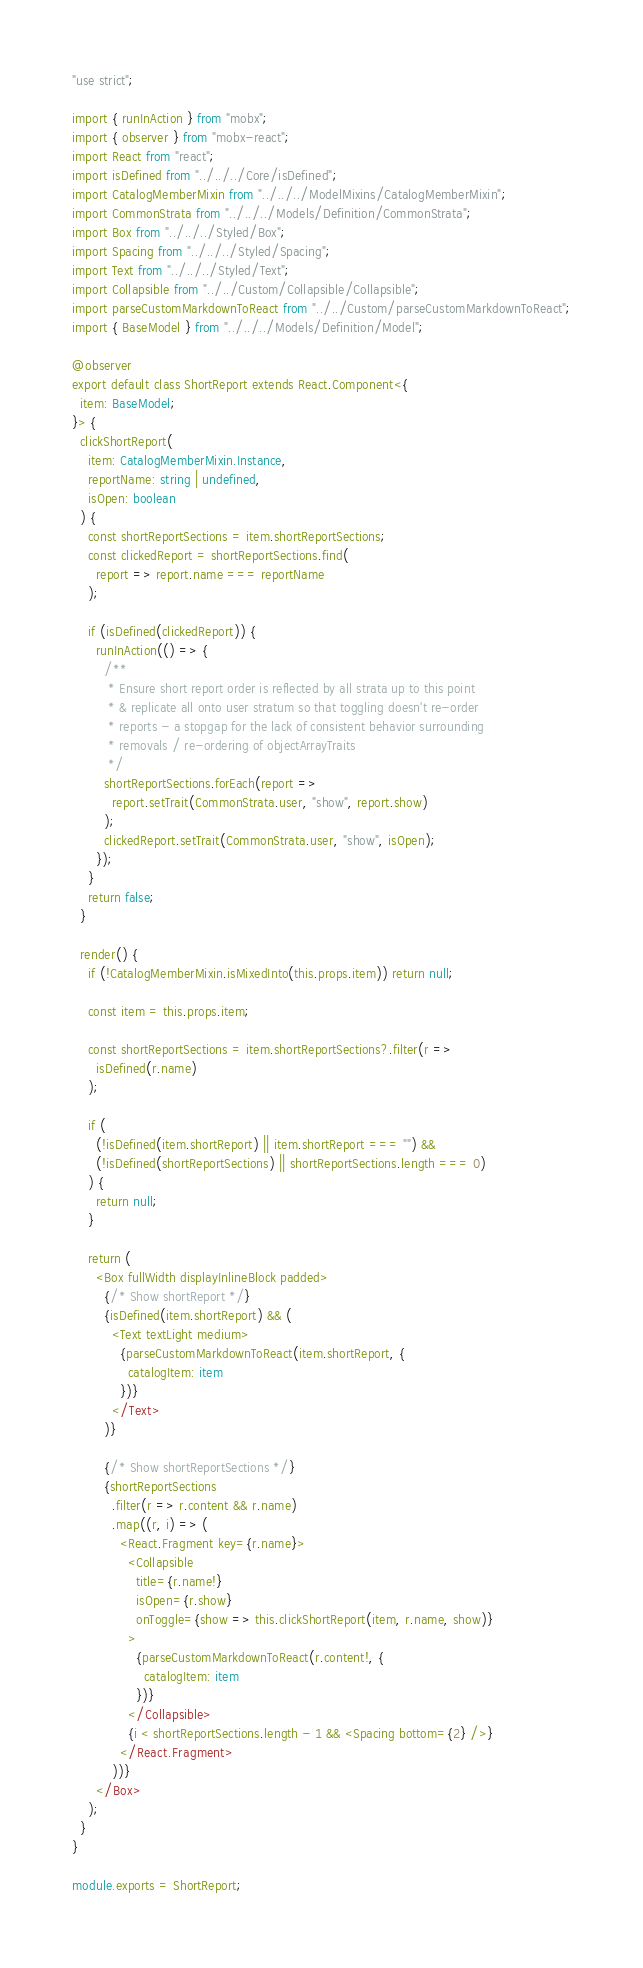Convert code to text. <code><loc_0><loc_0><loc_500><loc_500><_TypeScript_>"use strict";

import { runInAction } from "mobx";
import { observer } from "mobx-react";
import React from "react";
import isDefined from "../../../Core/isDefined";
import CatalogMemberMixin from "../../../ModelMixins/CatalogMemberMixin";
import CommonStrata from "../../../Models/Definition/CommonStrata";
import Box from "../../../Styled/Box";
import Spacing from "../../../Styled/Spacing";
import Text from "../../../Styled/Text";
import Collapsible from "../../Custom/Collapsible/Collapsible";
import parseCustomMarkdownToReact from "../../Custom/parseCustomMarkdownToReact";
import { BaseModel } from "../../../Models/Definition/Model";

@observer
export default class ShortReport extends React.Component<{
  item: BaseModel;
}> {
  clickShortReport(
    item: CatalogMemberMixin.Instance,
    reportName: string | undefined,
    isOpen: boolean
  ) {
    const shortReportSections = item.shortReportSections;
    const clickedReport = shortReportSections.find(
      report => report.name === reportName
    );

    if (isDefined(clickedReport)) {
      runInAction(() => {
        /**
         * Ensure short report order is reflected by all strata up to this point
         * & replicate all onto user stratum so that toggling doesn't re-order
         * reports - a stopgap for the lack of consistent behavior surrounding
         * removals / re-ordering of objectArrayTraits
         */
        shortReportSections.forEach(report =>
          report.setTrait(CommonStrata.user, "show", report.show)
        );
        clickedReport.setTrait(CommonStrata.user, "show", isOpen);
      });
    }
    return false;
  }

  render() {
    if (!CatalogMemberMixin.isMixedInto(this.props.item)) return null;

    const item = this.props.item;

    const shortReportSections = item.shortReportSections?.filter(r =>
      isDefined(r.name)
    );

    if (
      (!isDefined(item.shortReport) || item.shortReport === "") &&
      (!isDefined(shortReportSections) || shortReportSections.length === 0)
    ) {
      return null;
    }

    return (
      <Box fullWidth displayInlineBlock padded>
        {/* Show shortReport */}
        {isDefined(item.shortReport) && (
          <Text textLight medium>
            {parseCustomMarkdownToReact(item.shortReport, {
              catalogItem: item
            })}
          </Text>
        )}

        {/* Show shortReportSections */}
        {shortReportSections
          .filter(r => r.content && r.name)
          .map((r, i) => (
            <React.Fragment key={r.name}>
              <Collapsible
                title={r.name!}
                isOpen={r.show}
                onToggle={show => this.clickShortReport(item, r.name, show)}
              >
                {parseCustomMarkdownToReact(r.content!, {
                  catalogItem: item
                })}
              </Collapsible>
              {i < shortReportSections.length - 1 && <Spacing bottom={2} />}
            </React.Fragment>
          ))}
      </Box>
    );
  }
}

module.exports = ShortReport;
</code> 